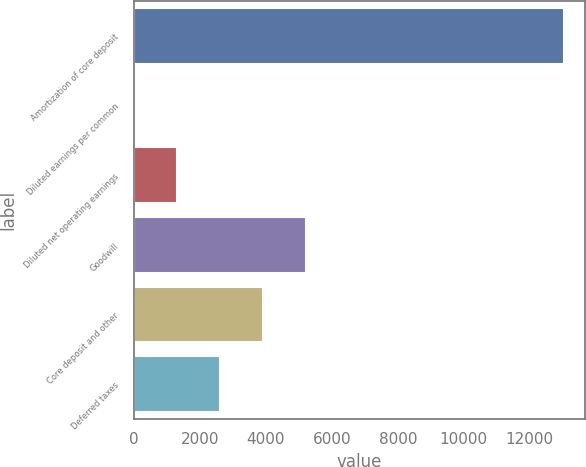Convert chart to OTSL. <chart><loc_0><loc_0><loc_500><loc_500><bar_chart><fcel>Amortization of core deposit<fcel>Diluted earnings per common<fcel>Diluted net operating earnings<fcel>Goodwill<fcel>Core deposit and other<fcel>Deferred taxes<nl><fcel>13028<fcel>1.77<fcel>1304.39<fcel>5212.25<fcel>3909.63<fcel>2607.01<nl></chart> 